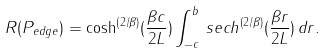<formula> <loc_0><loc_0><loc_500><loc_500>R ( P _ { e d g e } ) = \cosh ^ { \left ( { 2 / \beta } \right ) } ( { \frac { \beta c } { 2 L } } ) \int _ { - c } ^ { b } \, s e c h ^ { \left ( { 2 / \beta } \right ) } ( { \frac { \beta r } { 2 L } } ) \, d r .</formula> 